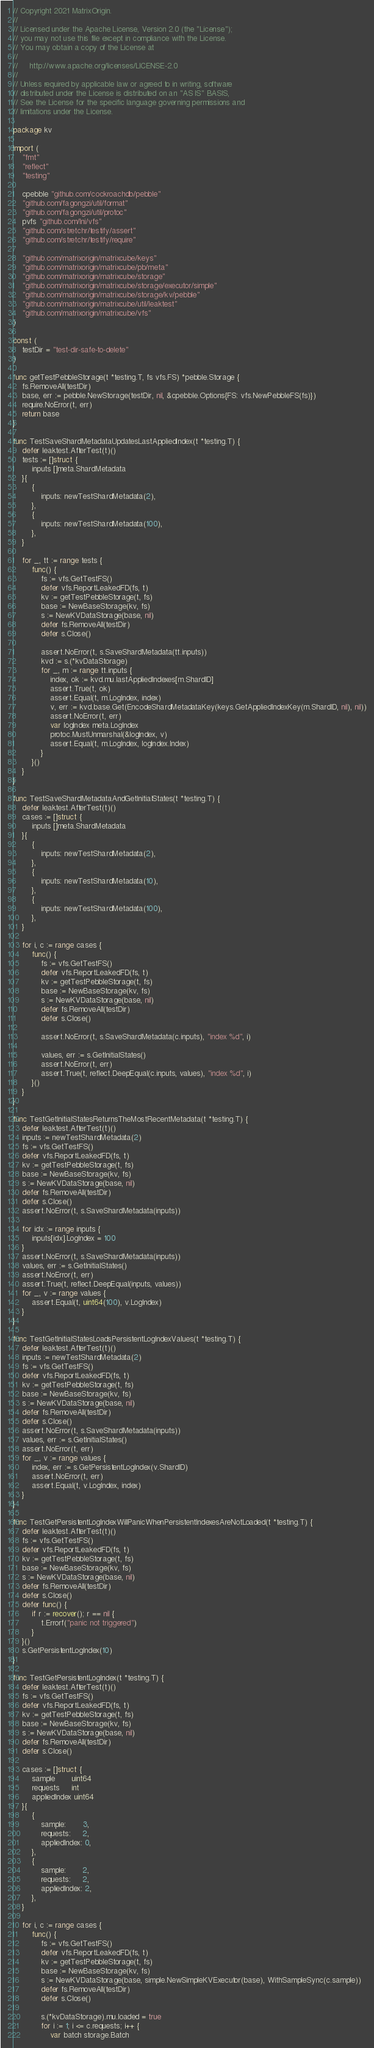<code> <loc_0><loc_0><loc_500><loc_500><_Go_>// Copyright 2021 MatrixOrigin.
//
// Licensed under the Apache License, Version 2.0 (the "License");
// you may not use this file except in compliance with the License.
// You may obtain a copy of the License at
//
//     http://www.apache.org/licenses/LICENSE-2.0
//
// Unless required by applicable law or agreed to in writing, software
// distributed under the License is distributed on an "AS IS" BASIS,
// See the License for the specific language governing permissions and
// limitations under the License.

package kv

import (
	"fmt"
	"reflect"
	"testing"

	cpebble "github.com/cockroachdb/pebble"
	"github.com/fagongzi/util/format"
	"github.com/fagongzi/util/protoc"
	pvfs "github.com/lni/vfs"
	"github.com/stretchr/testify/assert"
	"github.com/stretchr/testify/require"

	"github.com/matrixorigin/matrixcube/keys"
	"github.com/matrixorigin/matrixcube/pb/meta"
	"github.com/matrixorigin/matrixcube/storage"
	"github.com/matrixorigin/matrixcube/storage/executor/simple"
	"github.com/matrixorigin/matrixcube/storage/kv/pebble"
	"github.com/matrixorigin/matrixcube/util/leaktest"
	"github.com/matrixorigin/matrixcube/vfs"
)

const (
	testDir = "test-dir-safe-to-delete"
)

func getTestPebbleStorage(t *testing.T, fs vfs.FS) *pebble.Storage {
	fs.RemoveAll(testDir)
	base, err := pebble.NewStorage(testDir, nil, &cpebble.Options{FS: vfs.NewPebbleFS(fs)})
	require.NoError(t, err)
	return base
}

func TestSaveShardMetadataUpdatesLastAppliedIndex(t *testing.T) {
	defer leaktest.AfterTest(t)()
	tests := []struct {
		inputs []meta.ShardMetadata
	}{
		{
			inputs: newTestShardMetadata(2),
		},
		{
			inputs: newTestShardMetadata(100),
		},
	}

	for _, tt := range tests {
		func() {
			fs := vfs.GetTestFS()
			defer vfs.ReportLeakedFD(fs, t)
			kv := getTestPebbleStorage(t, fs)
			base := NewBaseStorage(kv, fs)
			s := NewKVDataStorage(base, nil)
			defer fs.RemoveAll(testDir)
			defer s.Close()

			assert.NoError(t, s.SaveShardMetadata(tt.inputs))
			kvd := s.(*kvDataStorage)
			for _, m := range tt.inputs {
				index, ok := kvd.mu.lastAppliedIndexes[m.ShardID]
				assert.True(t, ok)
				assert.Equal(t, m.LogIndex, index)
				v, err := kvd.base.Get(EncodeShardMetadataKey(keys.GetAppliedIndexKey(m.ShardID, nil), nil))
				assert.NoError(t, err)
				var logIndex meta.LogIndex
				protoc.MustUnmarshal(&logIndex, v)
				assert.Equal(t, m.LogIndex, logIndex.Index)
			}
		}()
	}
}

func TestSaveShardMetadataAndGetInitialStates(t *testing.T) {
	defer leaktest.AfterTest(t)()
	cases := []struct {
		inputs []meta.ShardMetadata
	}{
		{
			inputs: newTestShardMetadata(2),
		},
		{
			inputs: newTestShardMetadata(10),
		},
		{
			inputs: newTestShardMetadata(100),
		},
	}

	for i, c := range cases {
		func() {
			fs := vfs.GetTestFS()
			defer vfs.ReportLeakedFD(fs, t)
			kv := getTestPebbleStorage(t, fs)
			base := NewBaseStorage(kv, fs)
			s := NewKVDataStorage(base, nil)
			defer fs.RemoveAll(testDir)
			defer s.Close()

			assert.NoError(t, s.SaveShardMetadata(c.inputs), "index %d", i)

			values, err := s.GetInitialStates()
			assert.NoError(t, err)
			assert.True(t, reflect.DeepEqual(c.inputs, values), "index %d", i)
		}()
	}
}

func TestGetInitialStatesReturnsTheMostRecentMetadata(t *testing.T) {
	defer leaktest.AfterTest(t)()
	inputs := newTestShardMetadata(2)
	fs := vfs.GetTestFS()
	defer vfs.ReportLeakedFD(fs, t)
	kv := getTestPebbleStorage(t, fs)
	base := NewBaseStorage(kv, fs)
	s := NewKVDataStorage(base, nil)
	defer fs.RemoveAll(testDir)
	defer s.Close()
	assert.NoError(t, s.SaveShardMetadata(inputs))

	for idx := range inputs {
		inputs[idx].LogIndex = 100
	}
	assert.NoError(t, s.SaveShardMetadata(inputs))
	values, err := s.GetInitialStates()
	assert.NoError(t, err)
	assert.True(t, reflect.DeepEqual(inputs, values))
	for _, v := range values {
		assert.Equal(t, uint64(100), v.LogIndex)
	}
}

func TestGetInitialStatesLoadsPersistentLogIndexValues(t *testing.T) {
	defer leaktest.AfterTest(t)()
	inputs := newTestShardMetadata(2)
	fs := vfs.GetTestFS()
	defer vfs.ReportLeakedFD(fs, t)
	kv := getTestPebbleStorage(t, fs)
	base := NewBaseStorage(kv, fs)
	s := NewKVDataStorage(base, nil)
	defer fs.RemoveAll(testDir)
	defer s.Close()
	assert.NoError(t, s.SaveShardMetadata(inputs))
	values, err := s.GetInitialStates()
	assert.NoError(t, err)
	for _, v := range values {
		index, err := s.GetPersistentLogIndex(v.ShardID)
		assert.NoError(t, err)
		assert.Equal(t, v.LogIndex, index)
	}
}

func TestGetPersistentLogIndexWillPanicWhenPersistentIndexesAreNotLoaded(t *testing.T) {
	defer leaktest.AfterTest(t)()
	fs := vfs.GetTestFS()
	defer vfs.ReportLeakedFD(fs, t)
	kv := getTestPebbleStorage(t, fs)
	base := NewBaseStorage(kv, fs)
	s := NewKVDataStorage(base, nil)
	defer fs.RemoveAll(testDir)
	defer s.Close()
	defer func() {
		if r := recover(); r == nil {
			t.Errorf("panic not triggered")
		}
	}()
	s.GetPersistentLogIndex(10)
}

func TestGetPersistentLogIndex(t *testing.T) {
	defer leaktest.AfterTest(t)()
	fs := vfs.GetTestFS()
	defer vfs.ReportLeakedFD(fs, t)
	kv := getTestPebbleStorage(t, fs)
	base := NewBaseStorage(kv, fs)
	s := NewKVDataStorage(base, nil)
	defer fs.RemoveAll(testDir)
	defer s.Close()

	cases := []struct {
		sample       uint64
		requests     int
		appliedIndex uint64
	}{
		{
			sample:       3,
			requests:     2,
			appliedIndex: 0,
		},
		{
			sample:       2,
			requests:     2,
			appliedIndex: 2,
		},
	}

	for i, c := range cases {
		func() {
			fs := vfs.GetTestFS()
			defer vfs.ReportLeakedFD(fs, t)
			kv := getTestPebbleStorage(t, fs)
			base := NewBaseStorage(kv, fs)
			s := NewKVDataStorage(base, simple.NewSimpleKVExecutor(base), WithSampleSync(c.sample))
			defer fs.RemoveAll(testDir)
			defer s.Close()

			s.(*kvDataStorage).mu.loaded = true
			for i := 1; i <= c.requests; i++ {
				var batch storage.Batch</code> 